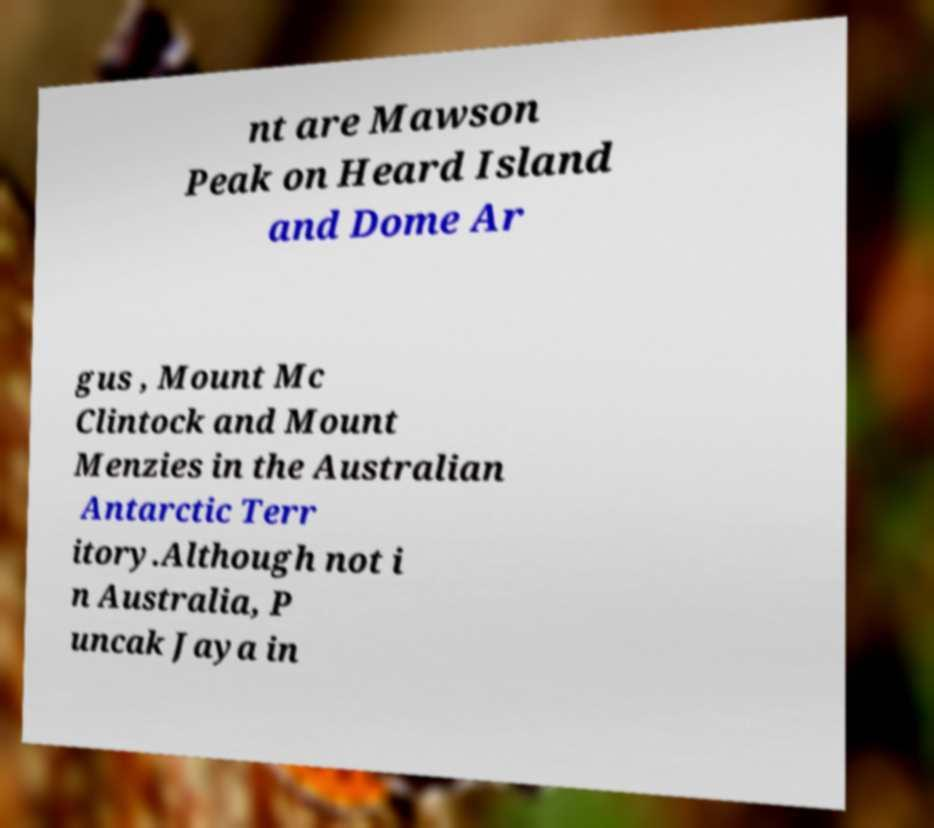I need the written content from this picture converted into text. Can you do that? nt are Mawson Peak on Heard Island and Dome Ar gus , Mount Mc Clintock and Mount Menzies in the Australian Antarctic Terr itory.Although not i n Australia, P uncak Jaya in 